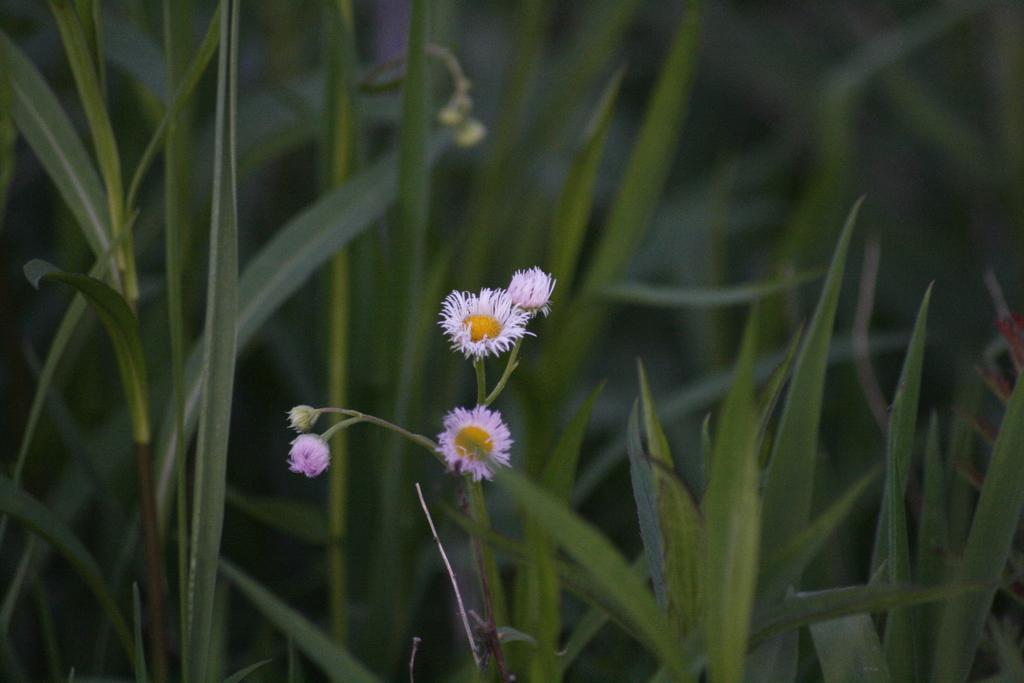Describe this image in one or two sentences. In this image we can see the flowers and also the stems. We can also see the grass in the background. 